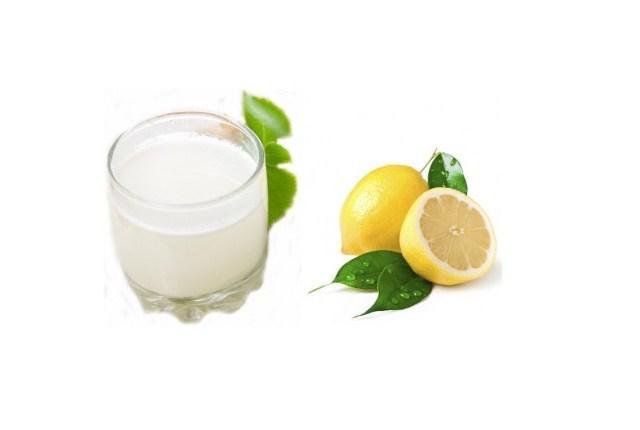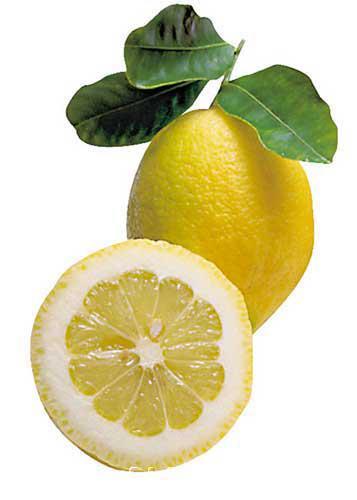The first image is the image on the left, the second image is the image on the right. Given the left and right images, does the statement "the image on the right contains only one full lemon and a half lemon" hold true? Answer yes or no. Yes. 